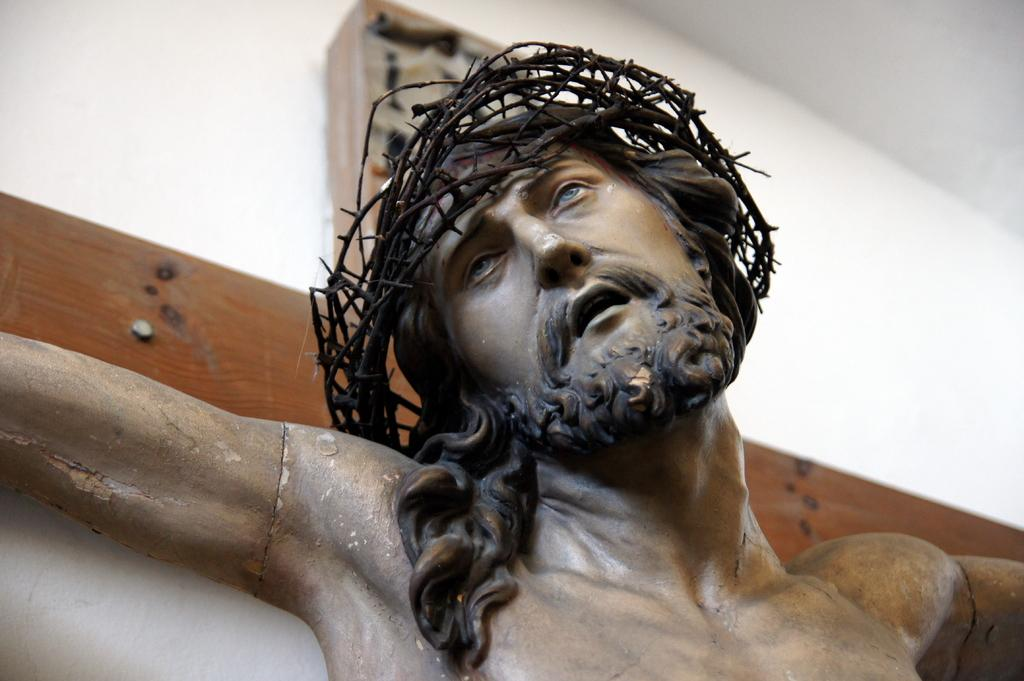Who is depicted in the image? There is a depiction of a man in the image. What is the man wearing or holding in the image? There is a thorn tiara in the image. What day of the week is depicted in the image? The image does not depict a day of the week; it features a man with a thorn tiara. What is the man's belief system in the image? The image does not provide information about the man's belief system. 